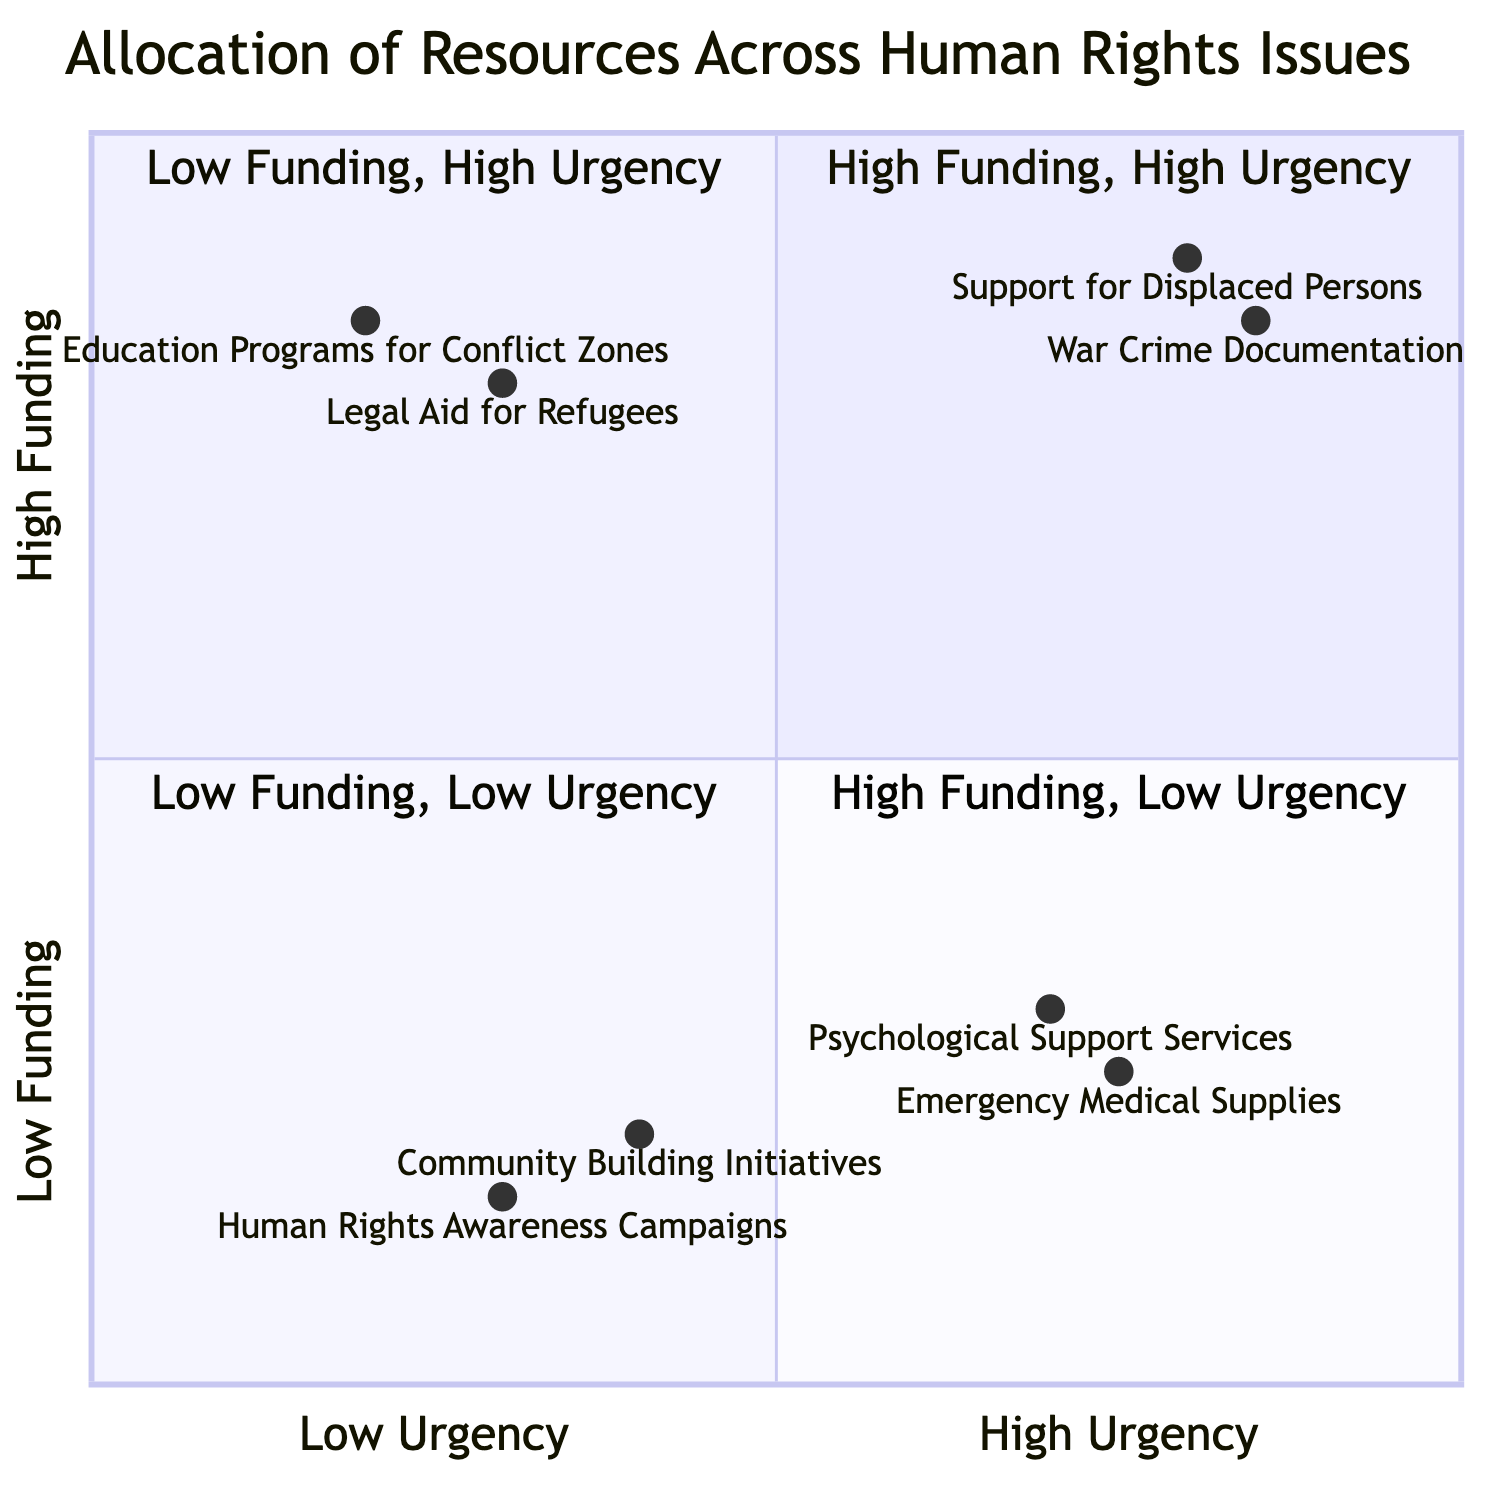What issues are placed in the High Funding, High Urgency quadrant? The diagram places "Support for Displaced Persons" and "War Crime Documentation" in the High Funding, High Urgency quadrant.
Answer: Support for Displaced Persons, War Crime Documentation How many issues have Low Funding and Low Urgency? There are two issues in the Low Funding, Low Urgency quadrant: "Community Building Initiatives" and "Human Rights Awareness Campaigns."
Answer: 2 Which issue has the highest urgency and low funding? "Psychological Support Services" has high urgency and low funding based on its position in the diagram.
Answer: Psychological Support Services In which quadrant is "Legal Aid for Refugees" located? "Legal Aid for Refugees" is located in the High Funding, Low Urgency quadrant, indicated by its coordinates on the diagram.
Answer: High Funding, Low Urgency Which issue has the lowest funding and what is its urgency level? "Human Rights Awareness Campaigns" has the lowest funding and a low urgency level, as shown in the diagram.
Answer: Low funding, Low urgency What is the relationship between Emergency Medical Supplies and Psychological Support Services in terms of funding? Both issues are in the Low Funding, High Urgency quadrant, indicating they share the same funding level of low but differ in the specific priorities for urgency.
Answer: Low funding How many total issues are represented in the diagram? There are a total of six issues represented across the four quadrants of the diagram: two in each of the first two quadrants and two in the last two.
Answer: 6 Which issue demonstrates a conflict between high funding and low urgency? "Education Programs for Conflict Zones" is the issue that demonstrates high funding while being categorized as low urgency in the diagram.
Answer: Education Programs for Conflict Zones What is the highest urgency issue that receives low funding? The highest urgency issue receiving low funding is "Psychological Support Services," according to its position in the diagram.
Answer: Psychological Support Services 